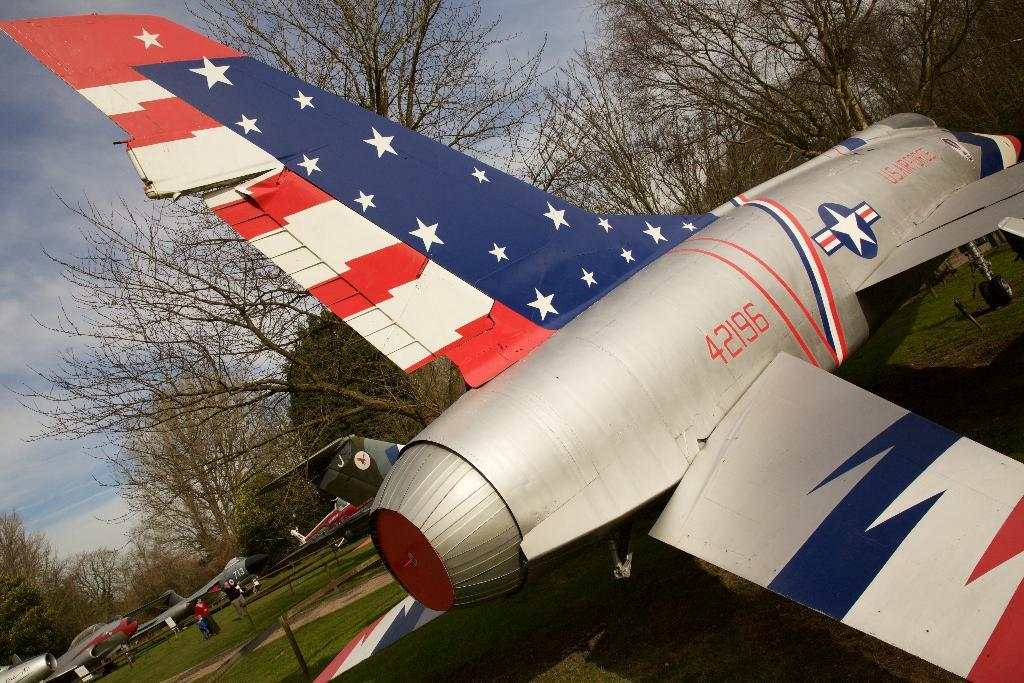Provide a one-sentence caption for the provided image. A plane with stars and stripes with the number 42196 printed on it. 